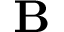<formula> <loc_0><loc_0><loc_500><loc_500>B</formula> 